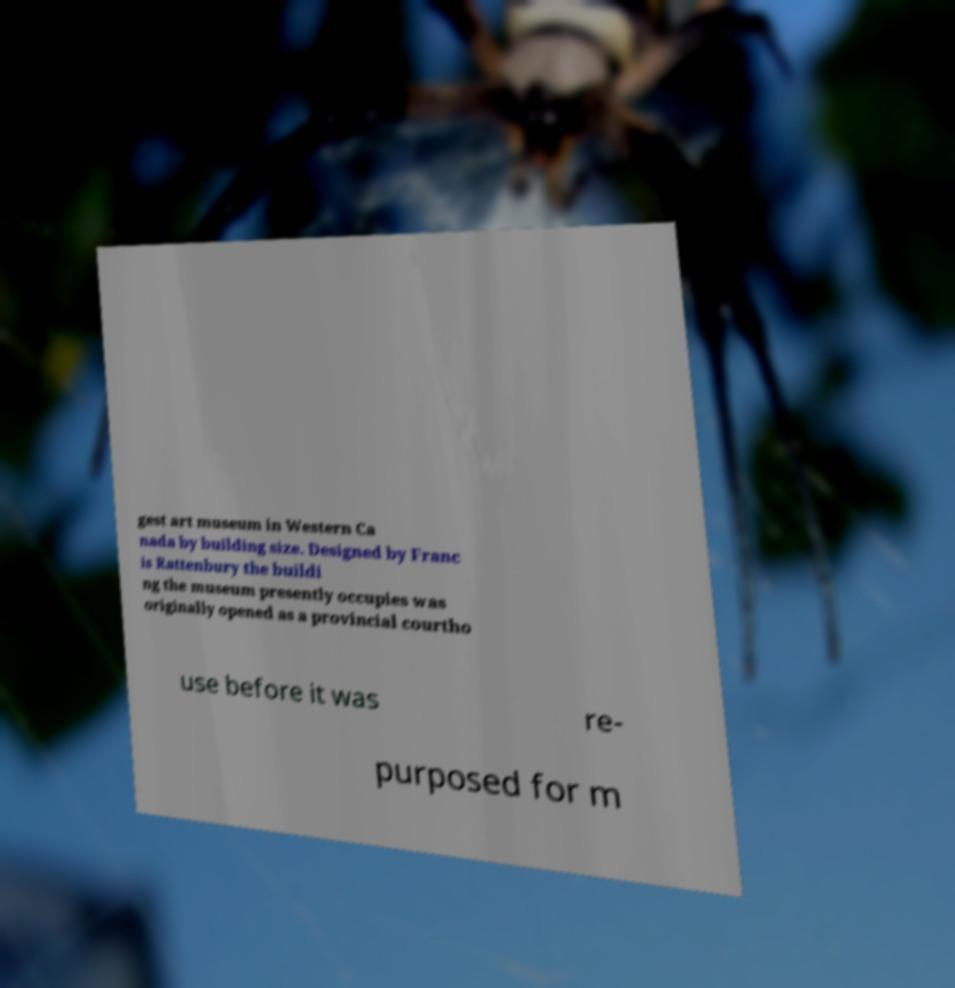For documentation purposes, I need the text within this image transcribed. Could you provide that? gest art museum in Western Ca nada by building size. Designed by Franc is Rattenbury the buildi ng the museum presently occupies was originally opened as a provincial courtho use before it was re- purposed for m 